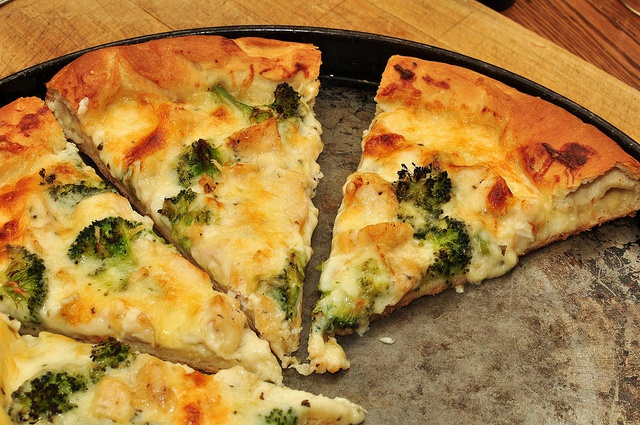Describe the objects in this image and their specific colors. I can see dining table in orange, tan, red, and olive tones, pizza in tan, orange, and khaki tones, pizza in tan, orange, red, and olive tones, pizza in tan, orange, red, and gold tones, and broccoli in tan, olive, and black tones in this image. 